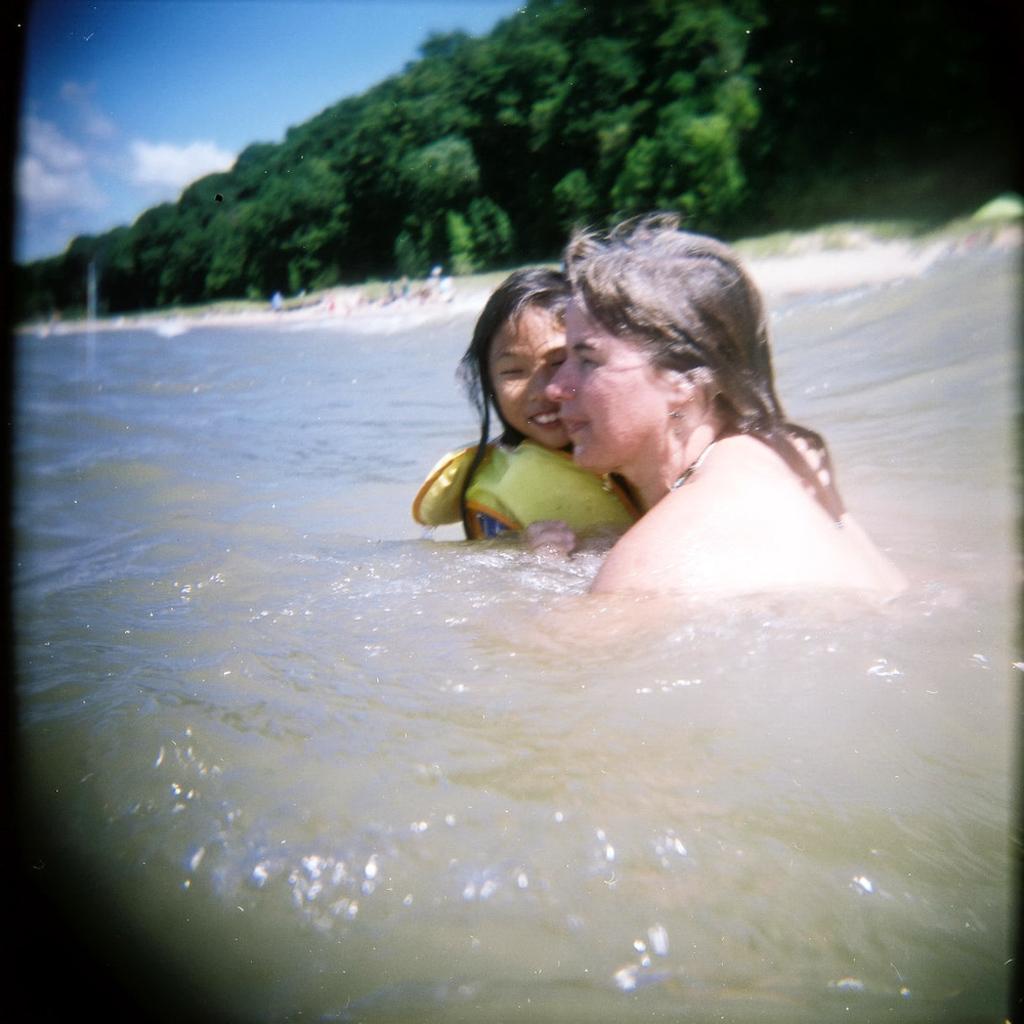Please provide a concise description of this image. In this image there is a beach, there are two persons in the water, there is sand, there are trees, there is the sky. 